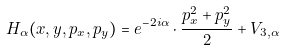<formula> <loc_0><loc_0><loc_500><loc_500>H _ { \alpha } ( x , y , p _ { x } , p _ { y } ) = e ^ { - 2 i \alpha } \cdot \frac { p _ { x } ^ { 2 } + p _ { y } ^ { 2 } } { 2 } + V _ { 3 , \alpha }</formula> 